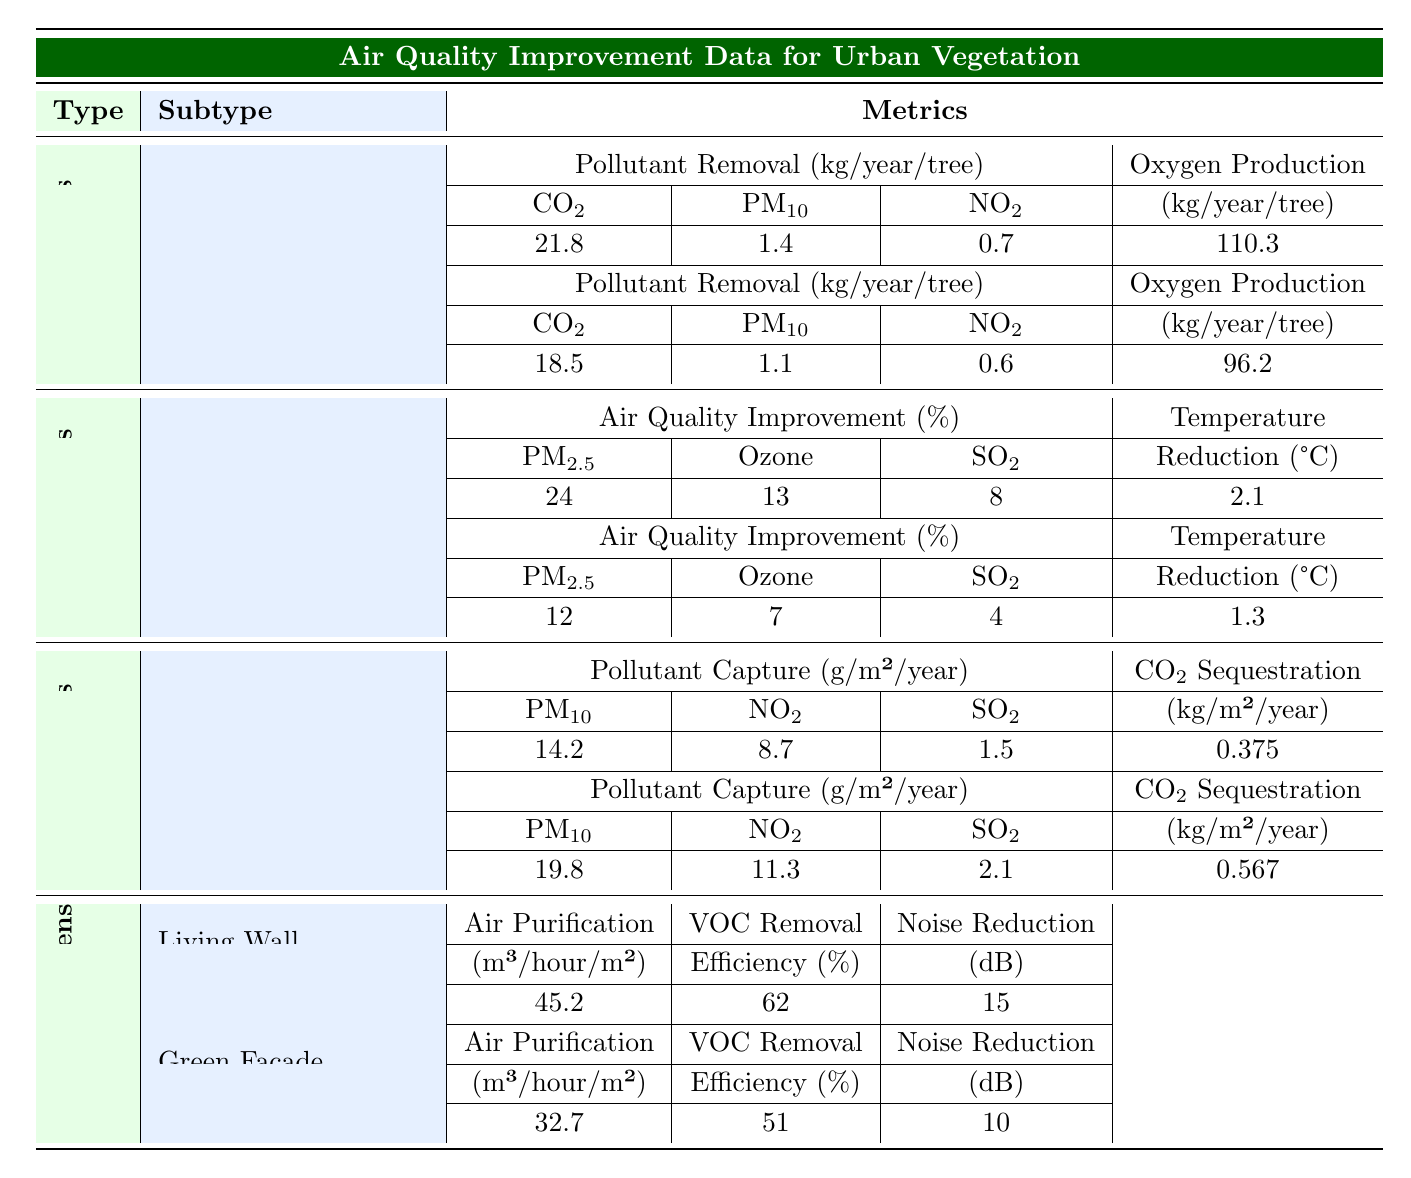What is the pollutant removal capacity for CO2 of a London Plane tree? The table shows that the London Plane tree removes 21.8 kg of CO2 per year.
Answer: 21.8 kg What is the highest percentage of PM2.5 air quality improvement among the urban vegetation types? The Mixed Woodland in Urban Parks improves PM2.5 air quality by 24%, which is the highest in the table.
Answer: 24% How much NO2 does an Intensive Mixed Herbs green roof capture per square meter per year? According to the table, the Intensive Mixed Herbs captures 11.3 g of NO2 per square meter per year.
Answer: 11.3 g What is the temperature reduction achieved by Grassland in Urban Parks? The table indicates that Grassland results in a temperature reduction of 1.3 °C.
Answer: 1.3 °C Which type of urban vegetation contributes the most to oxygen production per tree? The London Plane tree produces the most oxygen at 110.3 kg per year compared to Silver Birch, which produces 96.2 kg.
Answer: London Plane tree Which urban vegetation type has higher average air quality improvement for Ozone: Urban Parks or Green Roofs? The average Ozone air quality improvement in Urban Parks (10%) exceeds that of Green Roofs, which is not specified in the table but is generally lower for PM-related metrics.
Answer: Urban Parks What is the total amount of PM10 pollutant removal from both types of Street Trees? Adding the PM10 removal from London Plane (1.4) and Silver Birch (1.1) gives a total of 2.5 kg per year.
Answer: 2.5 kg Which urban vegetation type offers the highest air purification rate per square meter? The Living Wall has the highest air purification rate at 45.2 m³/hour/m² compared to Green Facade at 32.7 m³/hour/m².
Answer: Living Wall What is the total carbon sequestration provided by both types of Green Roof systems? Total CO2 sequestration: 0.375 kg/m²/year (Extensive Sedum) + 0.567 kg/m²/year (Intensive Mixed Herbs) = 0.942 kg/m²/year.
Answer: 0.942 kg/m²/year Is it true that Silver Birch has a higher NO2 removal capacity than London Plane? No, Silver Birch removes 0.6 kg of NO2 while London Plane removes 0.7 kg, so London Plane has a higher capacity.
Answer: No What is the average percentage of SO2 improvement provided by Mixed Woodland and Grassland in Urban Parks? The average is (8% from Mixed Woodland + 4% from Grassland) / 2 = 6%.
Answer: 6% Which vegetation type shows the least noise reduction capability according to the table? The Green Facade provides 10 dB of noise reduction, which is less than the Living Wall's 15 dB.
Answer: Green Facade 